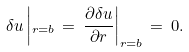<formula> <loc_0><loc_0><loc_500><loc_500>\delta u \left | _ { r = b } \, = \, \frac { \partial \delta u } { \partial r } \right | _ { r = b } \, = \, 0 .</formula> 